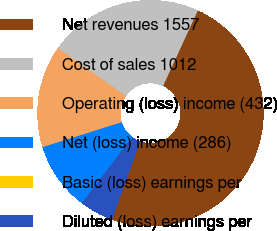<chart> <loc_0><loc_0><loc_500><loc_500><pie_chart><fcel>Net revenues 1557<fcel>Cost of sales 1012<fcel>Operating (loss) income (432)<fcel>Net (loss) income (286)<fcel>Basic (loss) earnings per<fcel>Diluted (loss) earnings per<nl><fcel>48.66%<fcel>22.13%<fcel>14.6%<fcel>9.74%<fcel>0.01%<fcel>4.87%<nl></chart> 